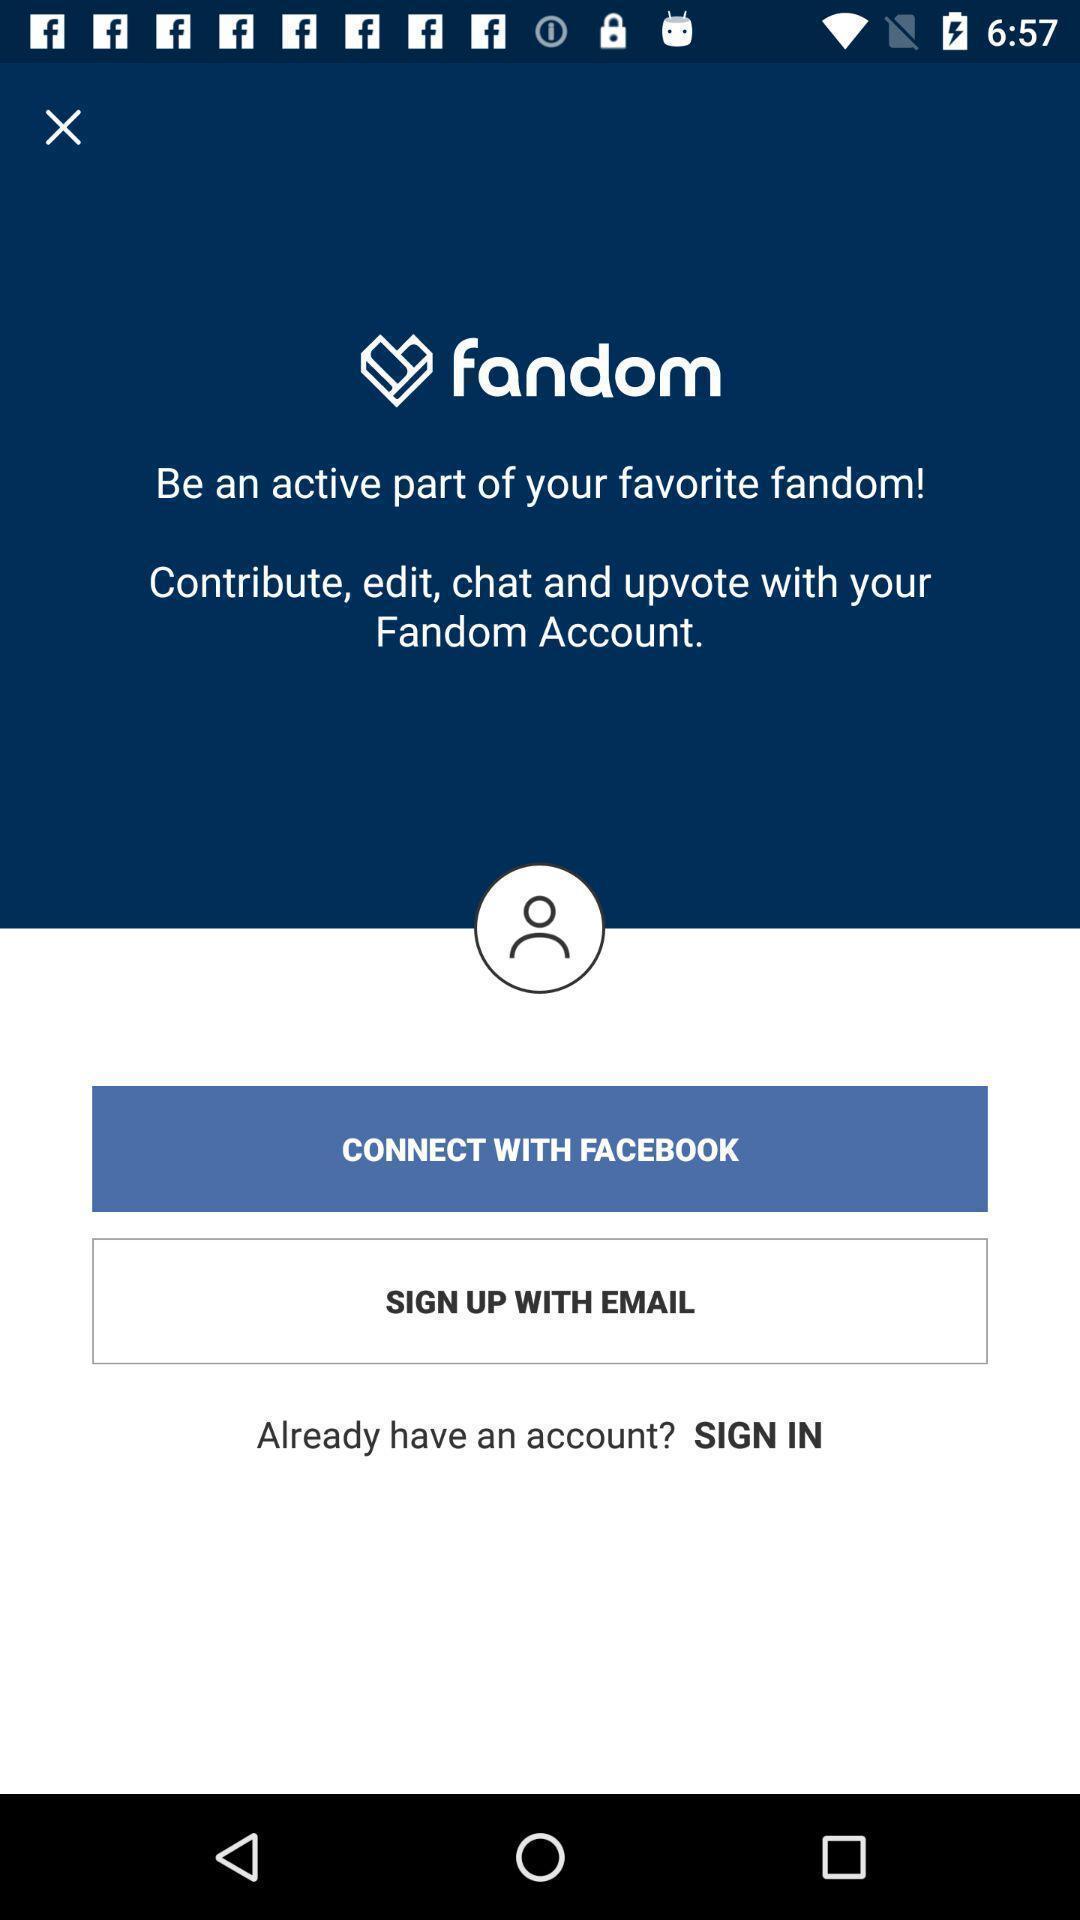What details can you identify in this image? Sign up page. 